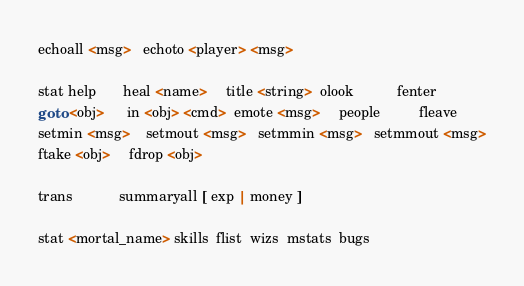Convert code to text. <code><loc_0><loc_0><loc_500><loc_500><_C_>echoall <msg>   echoto <player> <msg>

stat help       heal <name>     title <string>  olook           fenter
goto <obj>      in <obj> <cmd>  emote <msg>     people          fleave
setmin <msg>    setmout <msg>   setmmin <msg>   setmmout <msg>
ftake <obj>     fdrop <obj>

trans			summaryall [ exp | money ]

stat <mortal_name> skills  flist  wizs  mstats  bugs
</code> 